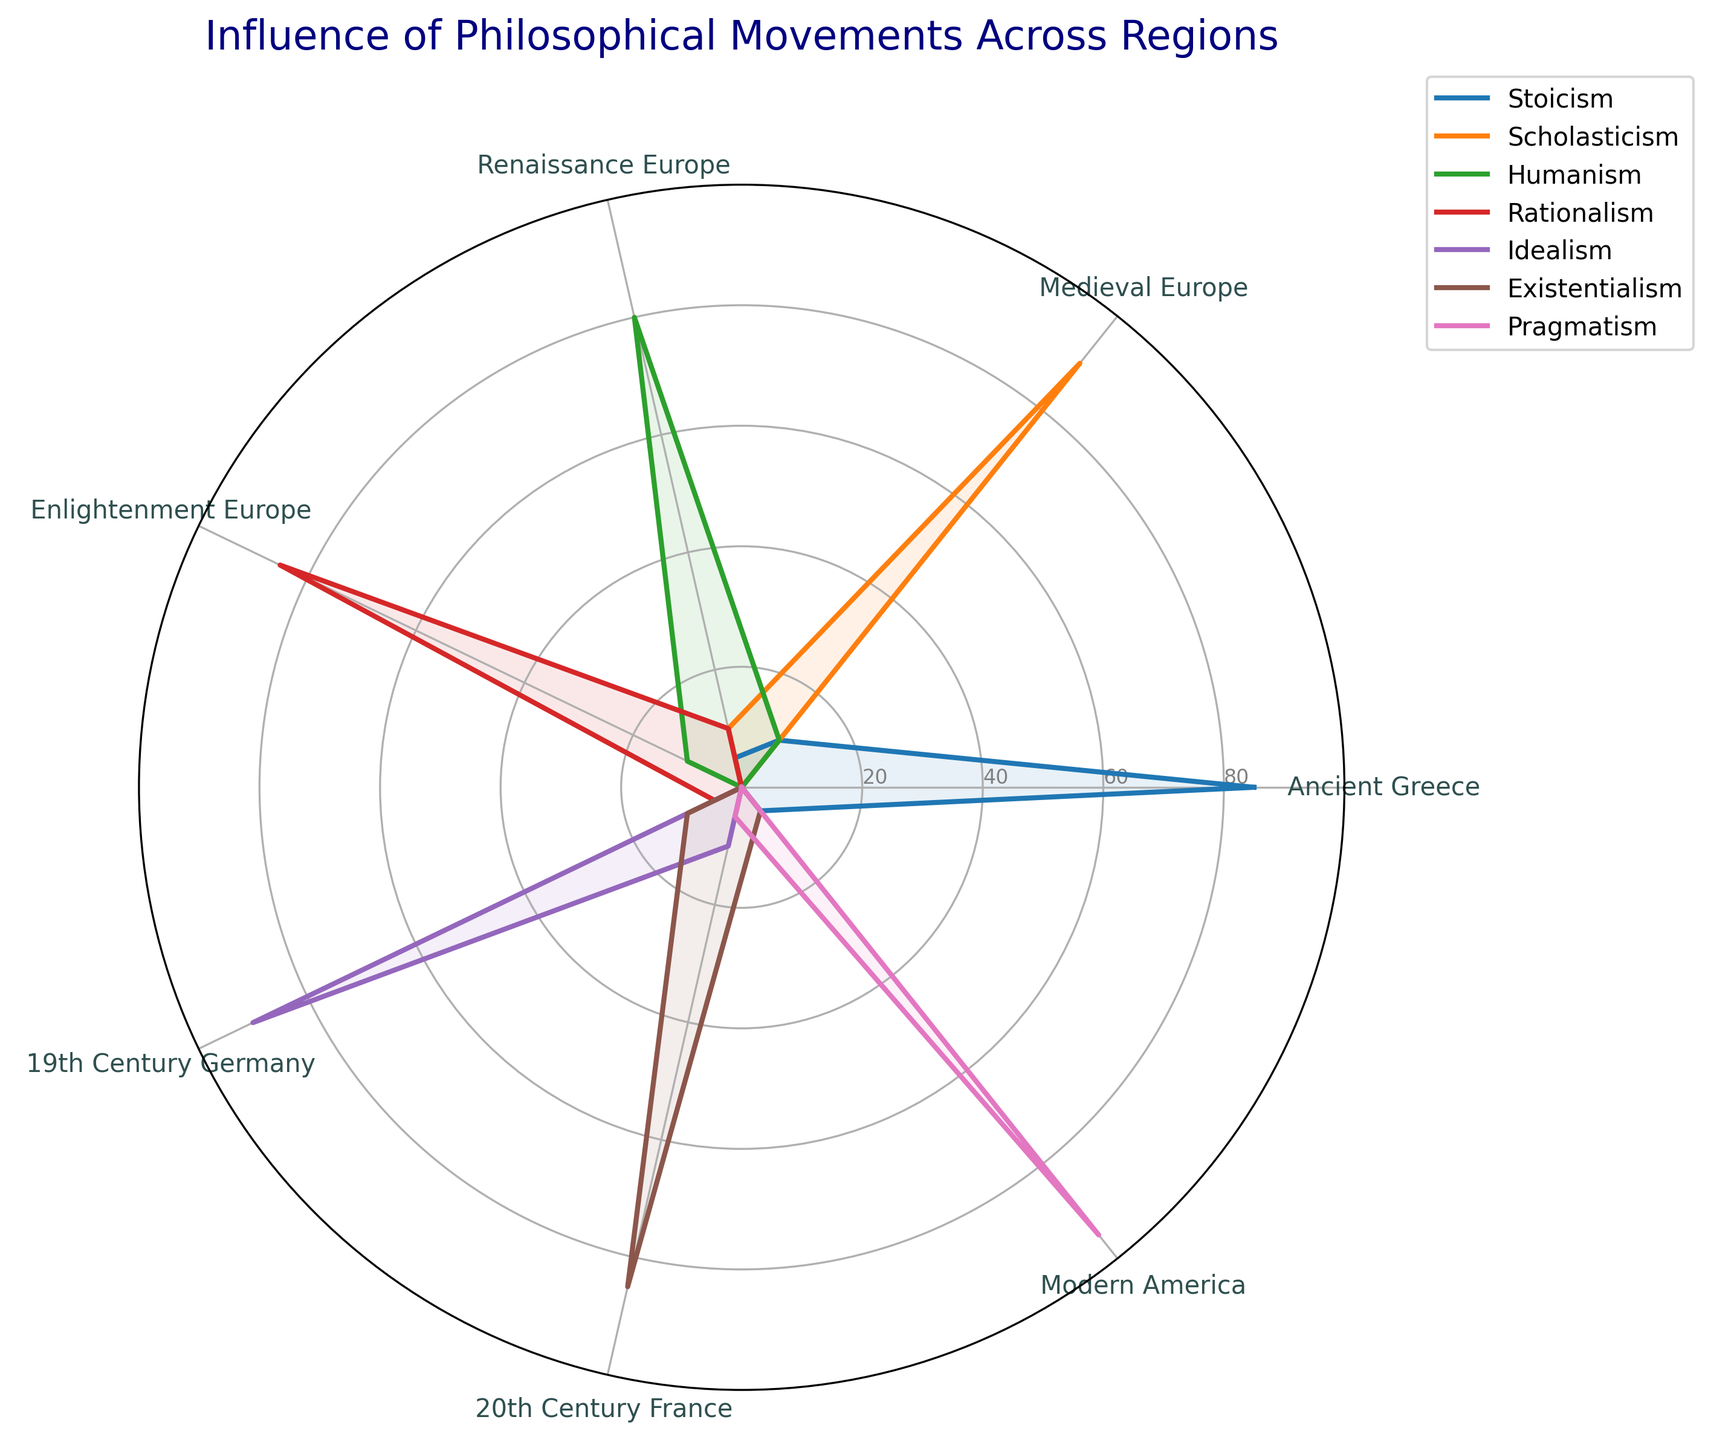What's the title of the chart? The title of the chart is generally located at the top of a figure. In this radar chart, we see a large title at the top naming the figure.
Answer: Influence of Philosophical Movements Across Regions Which region has the highest influence of Stoicism? By examining the radar chart, you identify the region with the highest value along the line labeled "Stoicism." The highest point for Stoicism is closest to "Ancient Greece."
Answer: Ancient Greece During which historical period did Existentialism have its most significant influence? To determine this, trace the line representing Existentialism. The highest point for this movement appears near "20th Century France."
Answer: 20th Century France What is the combined influence score of Stoicism in Ancient Greece and Modern America? According to the radar chart, locate the values for Stoicism in both regions. Stoicism has a score of 85 in Ancient Greece and 5 in Modern America. Adding them gives 85 + 5 = 90.
Answer: 90 How does the influence level of Rationalism in Enlightenment Europe compare to the influence level of Scholasticism in Medieval Europe? First, identify the influence levels of Rationalism in Enlightenment Europe and Scholasticism in Medieval Europe on the radar chart. Rationalism is 85, and Scholasticism is 90. Now, compare them.
Answer: Scholasticism in Medieval Europe is slightly higher Which philosophical movement has the most even distribution across all regions? By reviewing the radar chart, look for a movement with a relatively consistent influence level across multiple regions. Pragmatism seems to have a significant spread but mostly peaks in Modern America. Humanism has influence levels across Renaissance Europe, Medieval Europe, and Enlightenment Europe, but no movement is evenly distributed like Pragmatism stretches majorly into Modern America.
Answer: Pragmatism Calculate the average influence of Humanism across all periods. To find this, take the values corresponding to Humanism in all regions and compute their average: (0 + 10 + 80 + 10 + 0 + 0 + 0) / 7 = 100 / 7 ≈ 14.29.
Answer: ~14.29 Which two philosophical movements have the highest influence in the Enlightenment Europe period? Locate Enlightenment Europe on the radar chart, then identify the two highest points for the philosophical movements in this region. Rationalism has the highest score of 85, followed by Humanism with a score of 10.
Answer: Rationalism and Humanism How does the influence of Idealism in 19th Century Germany compare to its influence in 20th Century France? Check the radar chart's values for Idealism in both periods. Idealism scores 90 in 19th Century Germany and 10 in 20th Century France. Therefore, its influence in 19th Century Germany is significantly higher.
Answer: Idealism is higher in 19th Century Germany Which philosophical movement is almost exclusively associated with Modern America? By examining the radar chart, identify the movement with a significantly higher influence level in Modern America compared to other regions. Pragmatism stands out with a score of 95 in Modern America and low values elsewhere.
Answer: Pragmatism 